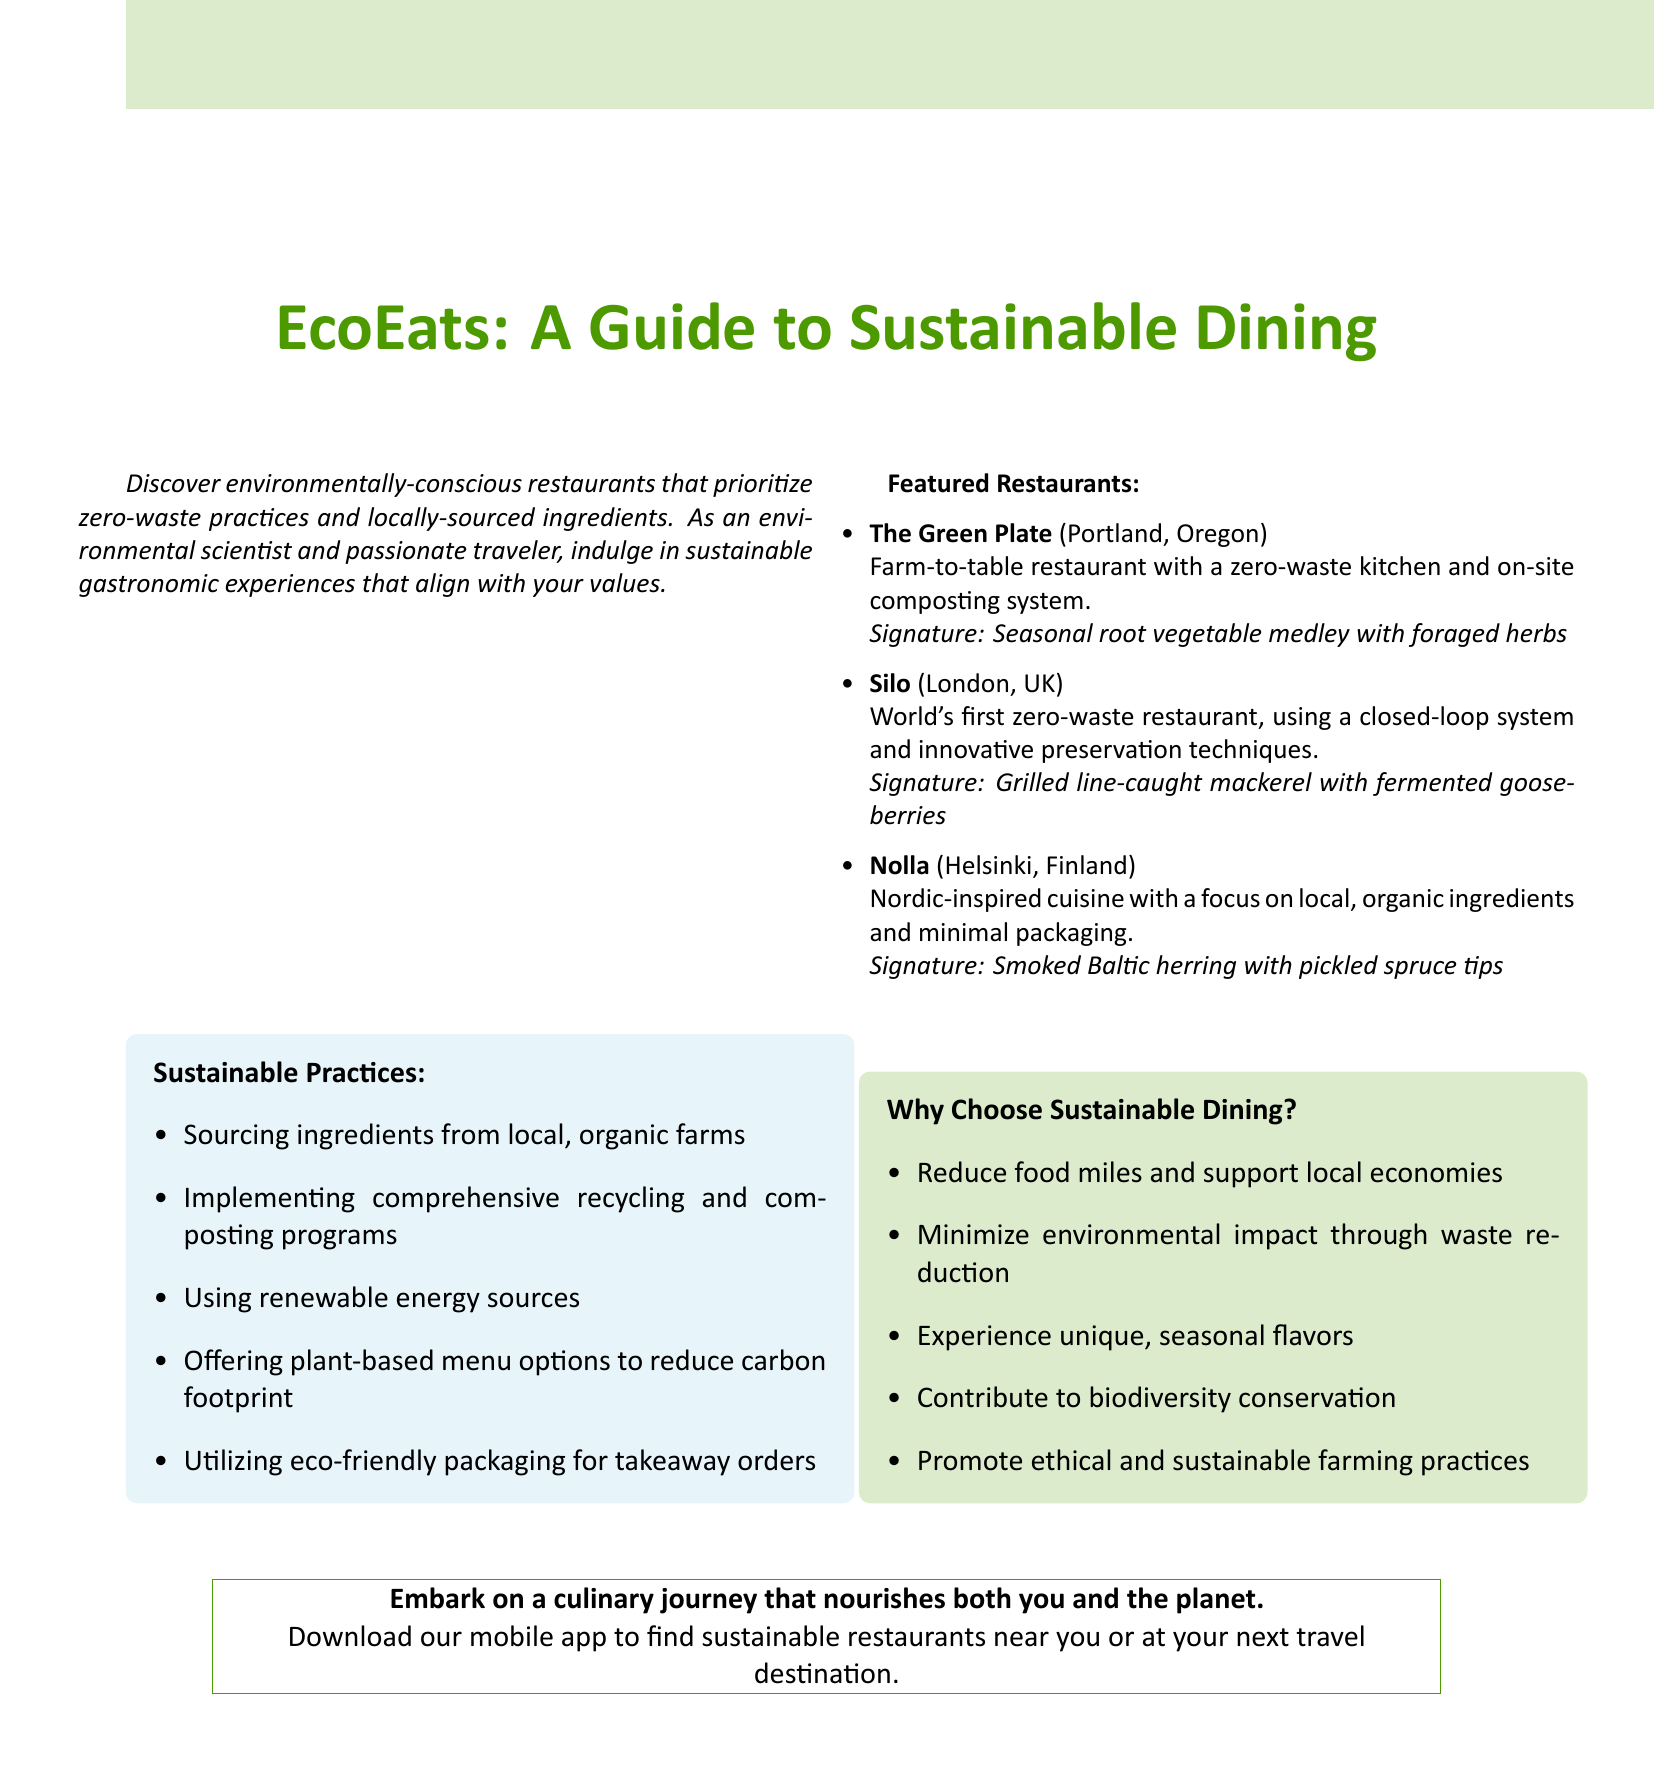What is the title of the document? The title is prominently displayed at the top of the document.
Answer: EcoEats: A Guide to Sustainable Dining How many featured restaurants are listed? The number of restaurants is indicated in the "Featured Restaurants" section.
Answer: 3 What is the location of The Green Plate? The location of The Green Plate is mentioned in its description.
Answer: Portland, Oregon What is a signature dish from Silo? The signature dish can be found listed under Silo in the document.
Answer: Grilled line-caught mackerel with fermented gooseberries What type of menu options do the restaurants offer to reduce carbon footprint? This information is highlighted in the "Sustainable Practices" section.
Answer: Plant-based menu options Why is it beneficial to choose sustainable dining? The document provides a list of reasons for choosing sustainable dining.
Answer: Reduce food miles and support local economies What type of restaurant is Nolla known for? The type of cuisine offered by Nolla is specified in the description.
Answer: Nordic-inspired cuisine How does Silo manage its waste? The document provides specific practices used by Silo.
Answer: Closed-loop system What can you do to find sustainable restaurants nearby? This is a call to action mentioned at the end of the document.
Answer: Download our mobile app 